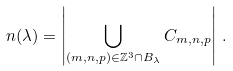Convert formula to latex. <formula><loc_0><loc_0><loc_500><loc_500>n ( \lambda ) = \left | \bigcup _ { ( m , n , p ) \in \mathbb { Z } ^ { 3 } \cap B _ { \lambda } } C _ { m , n , p } \right | \, .</formula> 